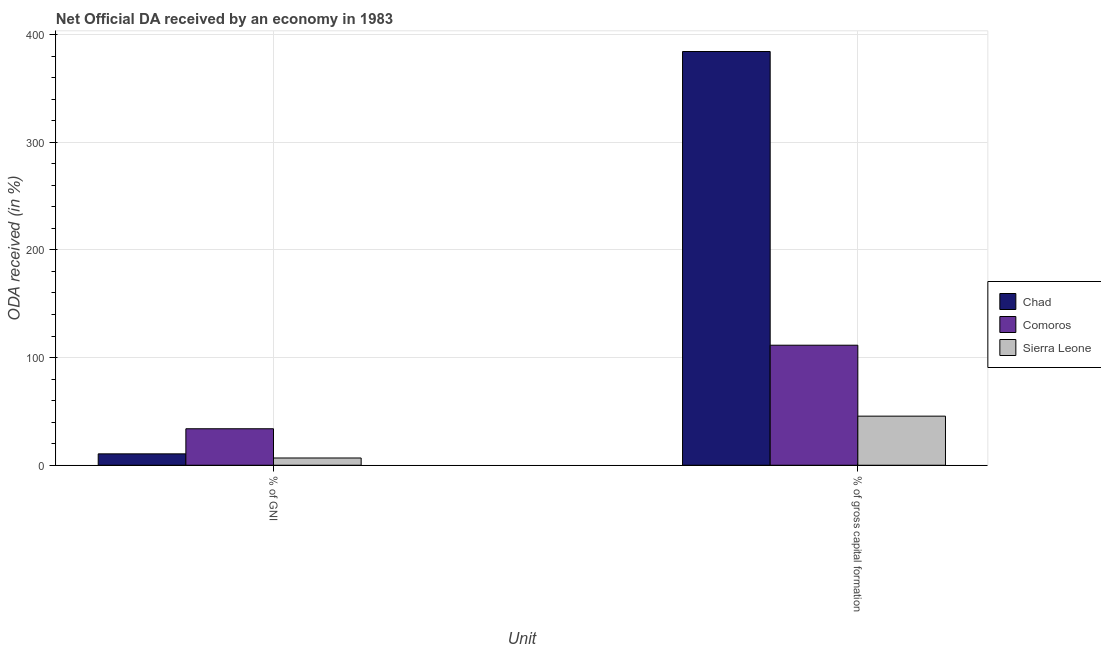How many different coloured bars are there?
Provide a short and direct response. 3. How many groups of bars are there?
Your answer should be very brief. 2. What is the label of the 2nd group of bars from the left?
Ensure brevity in your answer.  % of gross capital formation. What is the oda received as percentage of gni in Chad?
Offer a very short reply. 10.58. Across all countries, what is the maximum oda received as percentage of gni?
Your response must be concise. 33.9. Across all countries, what is the minimum oda received as percentage of gross capital formation?
Your answer should be very brief. 45.6. In which country was the oda received as percentage of gross capital formation maximum?
Provide a short and direct response. Chad. In which country was the oda received as percentage of gni minimum?
Keep it short and to the point. Sierra Leone. What is the total oda received as percentage of gross capital formation in the graph?
Offer a terse response. 541.42. What is the difference between the oda received as percentage of gni in Chad and that in Comoros?
Make the answer very short. -23.32. What is the difference between the oda received as percentage of gni in Chad and the oda received as percentage of gross capital formation in Sierra Leone?
Your answer should be compact. -35.03. What is the average oda received as percentage of gross capital formation per country?
Your response must be concise. 180.47. What is the difference between the oda received as percentage of gross capital formation and oda received as percentage of gni in Sierra Leone?
Give a very brief answer. 38.88. What is the ratio of the oda received as percentage of gross capital formation in Chad to that in Sierra Leone?
Provide a short and direct response. 8.43. In how many countries, is the oda received as percentage of gross capital formation greater than the average oda received as percentage of gross capital formation taken over all countries?
Keep it short and to the point. 1. What does the 3rd bar from the left in % of gross capital formation represents?
Ensure brevity in your answer.  Sierra Leone. What does the 3rd bar from the right in % of gross capital formation represents?
Make the answer very short. Chad. Are all the bars in the graph horizontal?
Your response must be concise. No. How many countries are there in the graph?
Give a very brief answer. 3. What is the difference between two consecutive major ticks on the Y-axis?
Offer a terse response. 100. Are the values on the major ticks of Y-axis written in scientific E-notation?
Make the answer very short. No. Does the graph contain any zero values?
Ensure brevity in your answer.  No. Does the graph contain grids?
Your answer should be compact. Yes. How are the legend labels stacked?
Your answer should be very brief. Vertical. What is the title of the graph?
Keep it short and to the point. Net Official DA received by an economy in 1983. Does "Middle East & North Africa (developing only)" appear as one of the legend labels in the graph?
Keep it short and to the point. No. What is the label or title of the X-axis?
Ensure brevity in your answer.  Unit. What is the label or title of the Y-axis?
Your answer should be compact. ODA received (in %). What is the ODA received (in %) of Chad in % of GNI?
Make the answer very short. 10.58. What is the ODA received (in %) in Comoros in % of GNI?
Give a very brief answer. 33.9. What is the ODA received (in %) of Sierra Leone in % of GNI?
Give a very brief answer. 6.73. What is the ODA received (in %) of Chad in % of gross capital formation?
Offer a terse response. 384.32. What is the ODA received (in %) of Comoros in % of gross capital formation?
Provide a short and direct response. 111.5. What is the ODA received (in %) in Sierra Leone in % of gross capital formation?
Offer a very short reply. 45.6. Across all Unit, what is the maximum ODA received (in %) of Chad?
Ensure brevity in your answer.  384.32. Across all Unit, what is the maximum ODA received (in %) in Comoros?
Give a very brief answer. 111.5. Across all Unit, what is the maximum ODA received (in %) of Sierra Leone?
Your answer should be very brief. 45.6. Across all Unit, what is the minimum ODA received (in %) of Chad?
Your response must be concise. 10.58. Across all Unit, what is the minimum ODA received (in %) in Comoros?
Your answer should be very brief. 33.9. Across all Unit, what is the minimum ODA received (in %) of Sierra Leone?
Your answer should be very brief. 6.73. What is the total ODA received (in %) of Chad in the graph?
Ensure brevity in your answer.  394.9. What is the total ODA received (in %) of Comoros in the graph?
Your answer should be compact. 145.39. What is the total ODA received (in %) in Sierra Leone in the graph?
Provide a short and direct response. 52.33. What is the difference between the ODA received (in %) of Chad in % of GNI and that in % of gross capital formation?
Your response must be concise. -373.75. What is the difference between the ODA received (in %) of Comoros in % of GNI and that in % of gross capital formation?
Your response must be concise. -77.6. What is the difference between the ODA received (in %) of Sierra Leone in % of GNI and that in % of gross capital formation?
Your answer should be very brief. -38.88. What is the difference between the ODA received (in %) in Chad in % of GNI and the ODA received (in %) in Comoros in % of gross capital formation?
Your answer should be compact. -100.92. What is the difference between the ODA received (in %) in Chad in % of GNI and the ODA received (in %) in Sierra Leone in % of gross capital formation?
Ensure brevity in your answer.  -35.03. What is the difference between the ODA received (in %) of Comoros in % of GNI and the ODA received (in %) of Sierra Leone in % of gross capital formation?
Keep it short and to the point. -11.71. What is the average ODA received (in %) in Chad per Unit?
Keep it short and to the point. 197.45. What is the average ODA received (in %) of Comoros per Unit?
Make the answer very short. 72.7. What is the average ODA received (in %) of Sierra Leone per Unit?
Your answer should be compact. 26.16. What is the difference between the ODA received (in %) in Chad and ODA received (in %) in Comoros in % of GNI?
Your response must be concise. -23.32. What is the difference between the ODA received (in %) of Chad and ODA received (in %) of Sierra Leone in % of GNI?
Offer a terse response. 3.85. What is the difference between the ODA received (in %) in Comoros and ODA received (in %) in Sierra Leone in % of GNI?
Your answer should be very brief. 27.17. What is the difference between the ODA received (in %) in Chad and ODA received (in %) in Comoros in % of gross capital formation?
Your answer should be very brief. 272.83. What is the difference between the ODA received (in %) in Chad and ODA received (in %) in Sierra Leone in % of gross capital formation?
Provide a succinct answer. 338.72. What is the difference between the ODA received (in %) in Comoros and ODA received (in %) in Sierra Leone in % of gross capital formation?
Provide a short and direct response. 65.89. What is the ratio of the ODA received (in %) of Chad in % of GNI to that in % of gross capital formation?
Provide a succinct answer. 0.03. What is the ratio of the ODA received (in %) in Comoros in % of GNI to that in % of gross capital formation?
Provide a short and direct response. 0.3. What is the ratio of the ODA received (in %) of Sierra Leone in % of GNI to that in % of gross capital formation?
Give a very brief answer. 0.15. What is the difference between the highest and the second highest ODA received (in %) of Chad?
Give a very brief answer. 373.75. What is the difference between the highest and the second highest ODA received (in %) in Comoros?
Ensure brevity in your answer.  77.6. What is the difference between the highest and the second highest ODA received (in %) of Sierra Leone?
Give a very brief answer. 38.88. What is the difference between the highest and the lowest ODA received (in %) in Chad?
Your answer should be very brief. 373.75. What is the difference between the highest and the lowest ODA received (in %) of Comoros?
Give a very brief answer. 77.6. What is the difference between the highest and the lowest ODA received (in %) of Sierra Leone?
Your answer should be very brief. 38.88. 